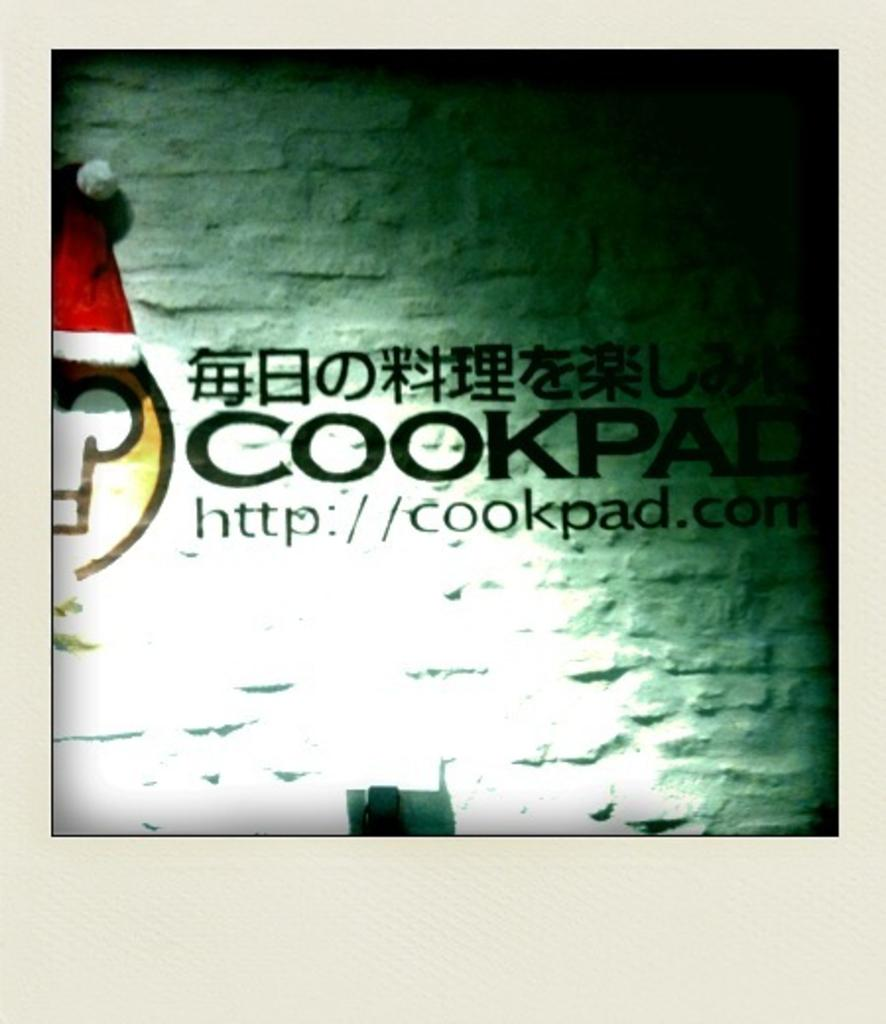What type of image is being described? The image is a photo. What additional elements can be found in the photo? There is text and a logo on the wall in the photo. How many rings are visible on the person's fingers in the photo? There are no rings visible on any person's fingers in the photo. What date is marked on the calendar in the photo? There is no calendar present in the photo. 